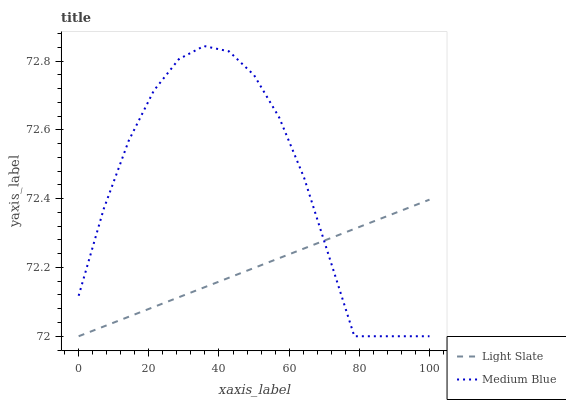Does Light Slate have the minimum area under the curve?
Answer yes or no. Yes. Does Medium Blue have the maximum area under the curve?
Answer yes or no. Yes. Does Medium Blue have the minimum area under the curve?
Answer yes or no. No. Is Light Slate the smoothest?
Answer yes or no. Yes. Is Medium Blue the roughest?
Answer yes or no. Yes. Is Medium Blue the smoothest?
Answer yes or no. No. Does Light Slate have the lowest value?
Answer yes or no. Yes. Does Medium Blue have the highest value?
Answer yes or no. Yes. Does Medium Blue intersect Light Slate?
Answer yes or no. Yes. Is Medium Blue less than Light Slate?
Answer yes or no. No. Is Medium Blue greater than Light Slate?
Answer yes or no. No. 